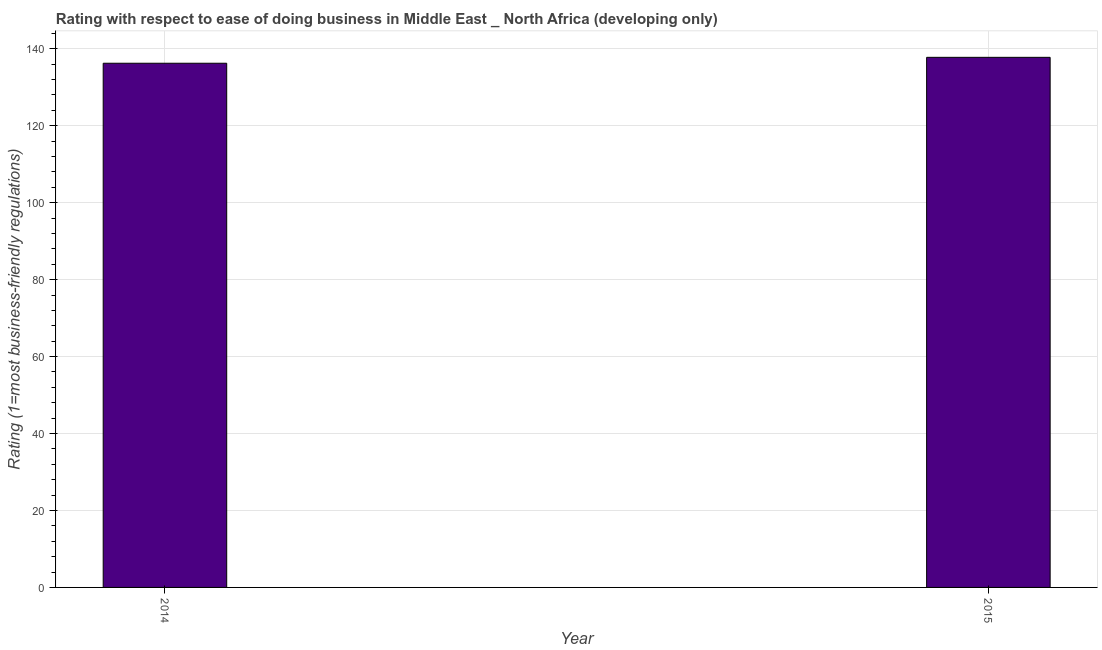Does the graph contain any zero values?
Keep it short and to the point. No. Does the graph contain grids?
Provide a succinct answer. Yes. What is the title of the graph?
Your response must be concise. Rating with respect to ease of doing business in Middle East _ North Africa (developing only). What is the label or title of the X-axis?
Offer a very short reply. Year. What is the label or title of the Y-axis?
Provide a succinct answer. Rating (1=most business-friendly regulations). What is the ease of doing business index in 2015?
Keep it short and to the point. 137.77. Across all years, what is the maximum ease of doing business index?
Keep it short and to the point. 137.77. Across all years, what is the minimum ease of doing business index?
Your response must be concise. 136.23. In which year was the ease of doing business index maximum?
Your answer should be very brief. 2015. What is the sum of the ease of doing business index?
Offer a terse response. 274. What is the difference between the ease of doing business index in 2014 and 2015?
Ensure brevity in your answer.  -1.54. What is the average ease of doing business index per year?
Provide a succinct answer. 137. What is the median ease of doing business index?
Your answer should be compact. 137. In how many years, is the ease of doing business index greater than 92 ?
Offer a terse response. 2. Do a majority of the years between 2015 and 2014 (inclusive) have ease of doing business index greater than 88 ?
Your answer should be very brief. No. In how many years, is the ease of doing business index greater than the average ease of doing business index taken over all years?
Give a very brief answer. 1. Are all the bars in the graph horizontal?
Provide a succinct answer. No. Are the values on the major ticks of Y-axis written in scientific E-notation?
Ensure brevity in your answer.  No. What is the Rating (1=most business-friendly regulations) in 2014?
Your answer should be compact. 136.23. What is the Rating (1=most business-friendly regulations) in 2015?
Offer a terse response. 137.77. What is the difference between the Rating (1=most business-friendly regulations) in 2014 and 2015?
Your answer should be compact. -1.54. What is the ratio of the Rating (1=most business-friendly regulations) in 2014 to that in 2015?
Provide a short and direct response. 0.99. 